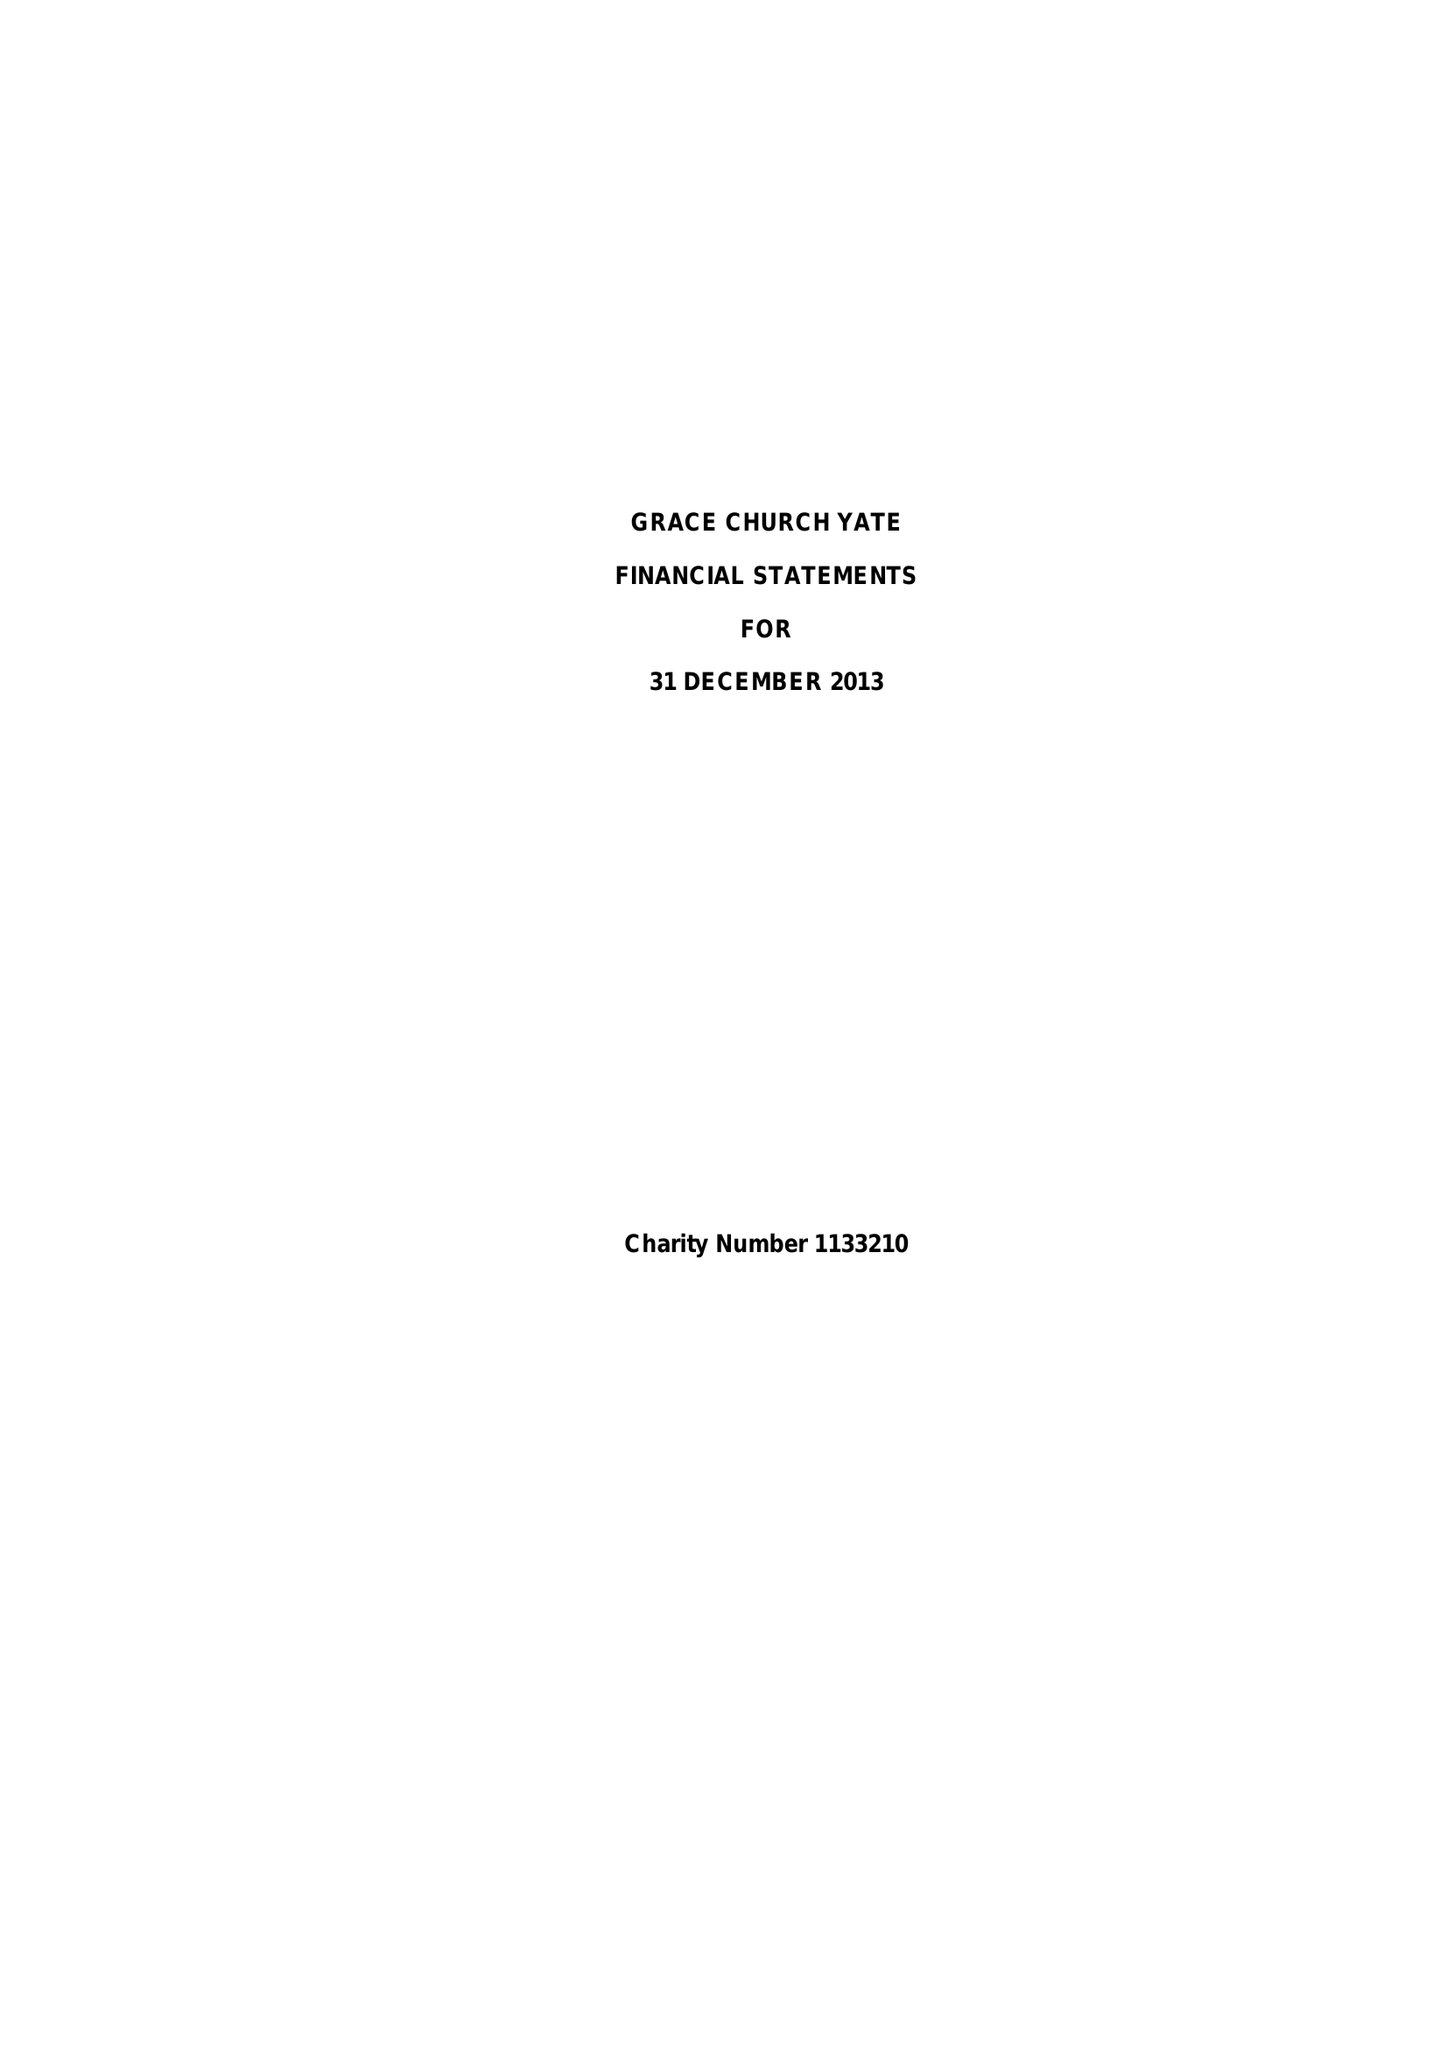What is the value for the address__postcode?
Answer the question using a single word or phrase. BS36 2JZ 